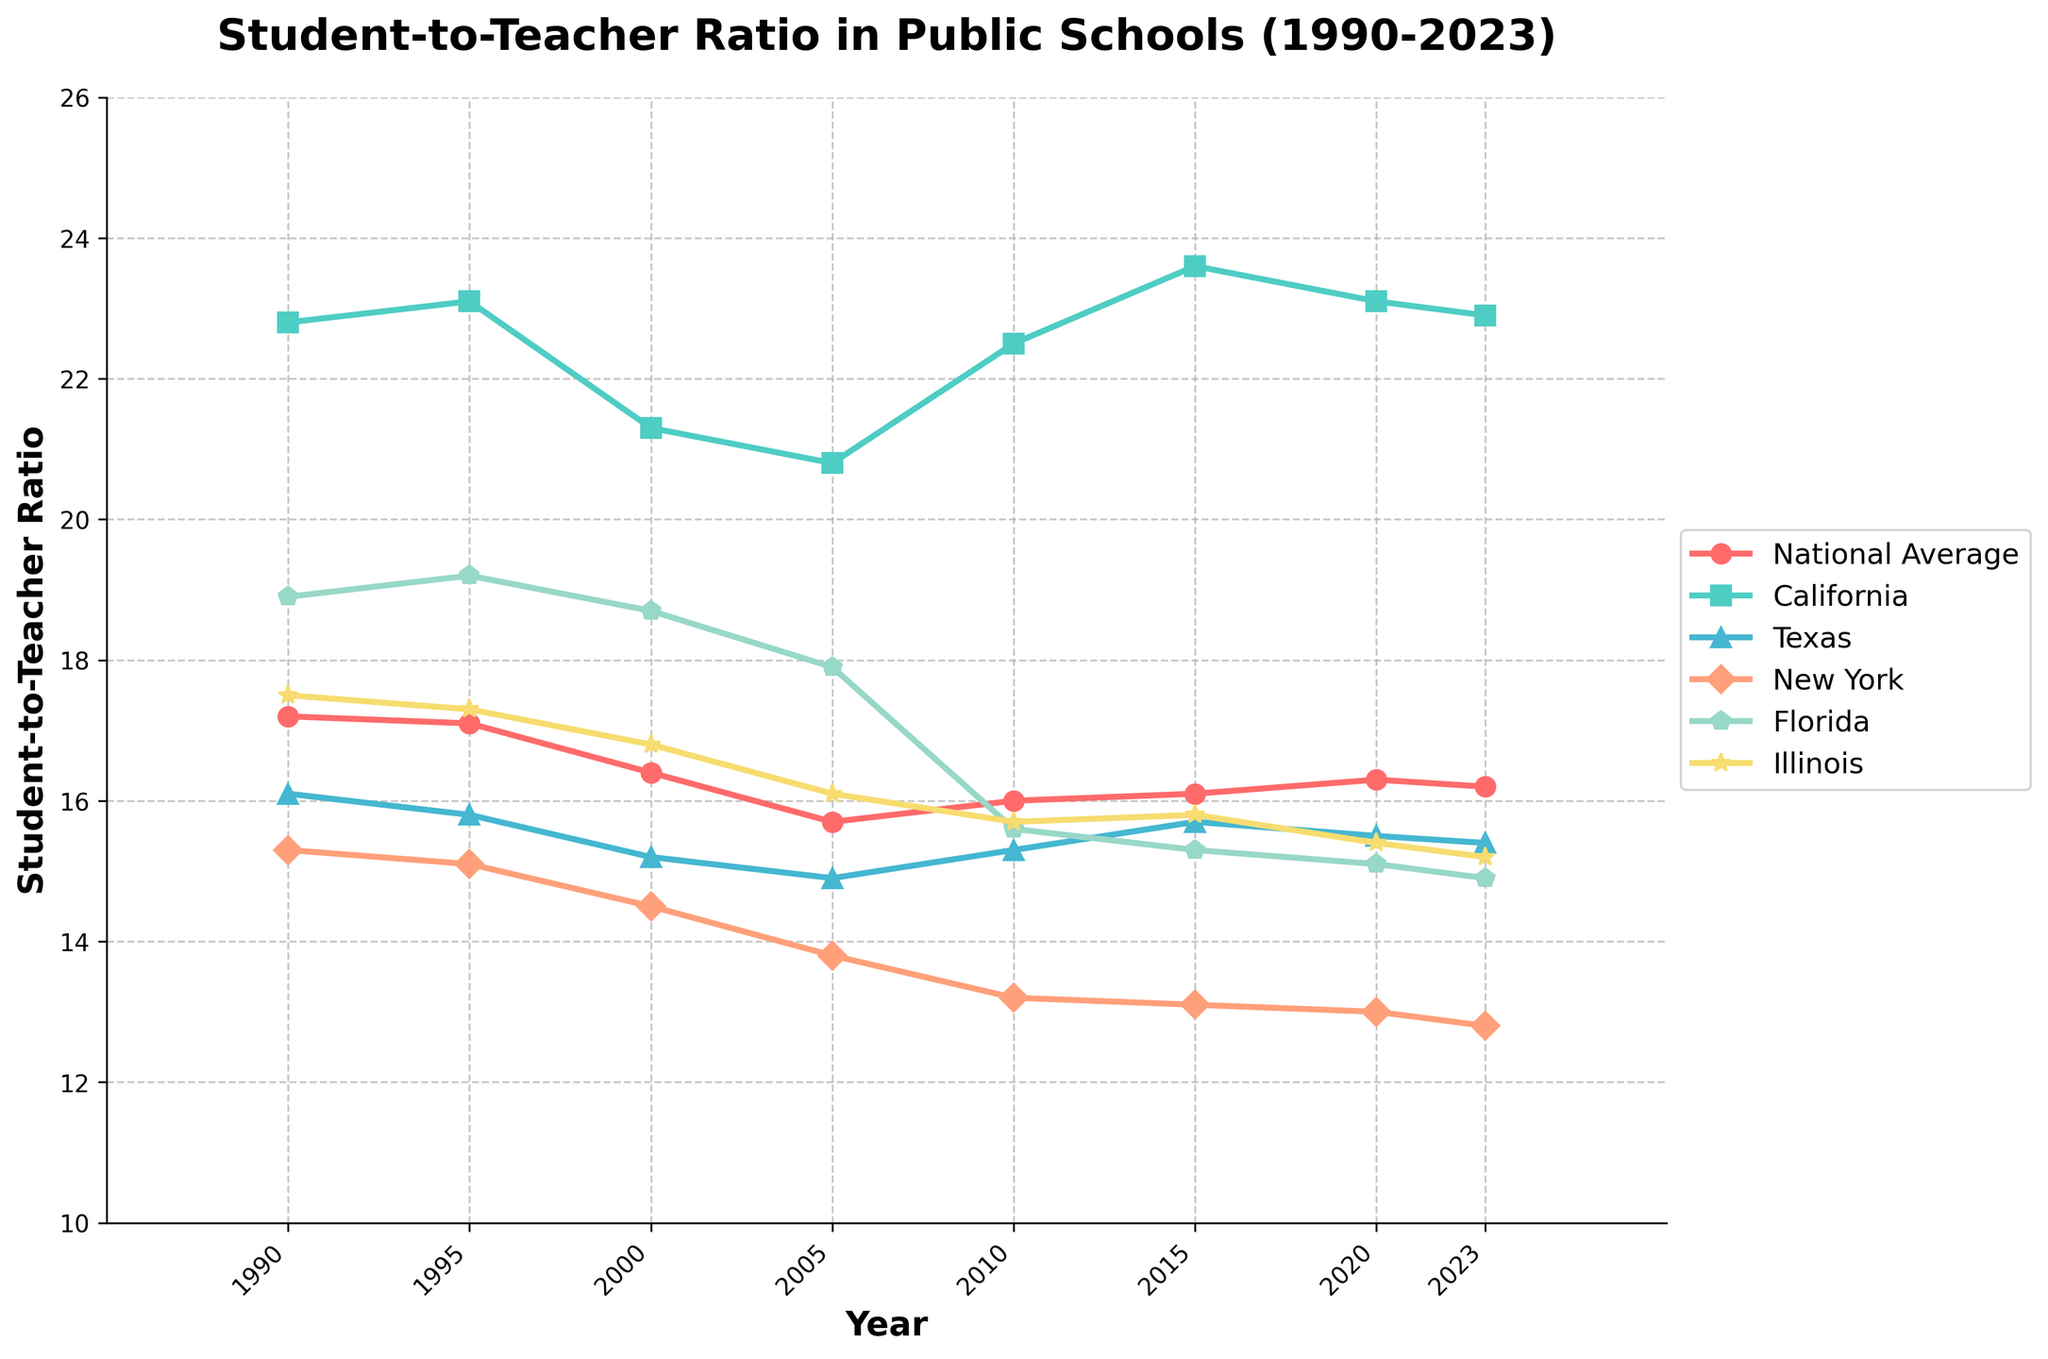What trend does the student-to-teacher ratio in New York show from 1990 to 2023? From the graph, we can observe that the student-to-teacher ratio in New York shows a consistent downward trend from 1990 to 2023. Starting at 15.3 in 1990 and ending at 12.8 in 2023, it generally decreases over the years.
Answer: Downward trend How does the student-to-teacher ratio in Florida in 2023 compare to the year 2000? Looking at the values in the plot for Florida, the student-to-teacher ratio was 18.7 in 2000 and decreased to 14.9 in 2023. This shows a decrease in the student-to-teacher ratio over this period.
Answer: Decreased Which state had the highest student-to-teacher ratio in both 1990 and 2023? The highest student-to-teacher ratio in 1990 was in California at 22.8. In 2023, California still had the highest ratio at 22.9 compared to other states.
Answer: California What is the average student-to-teacher ratio for Texas from 1990 to 2023? To find the average, sum the student-to-teacher ratios for Texas across the years 1990 (16.1), 1995 (15.8), 2000 (15.2), 2005 (14.9), 2010 (15.3), 2015 (15.7), 2020 (15.5), 2023 (15.4). This gives a sum of 124.9. Dividing by 8 (number of years) gives an average of 15.6.
Answer: 15.6 In which year did the national average student-to-teacher ratio hit its lowest point, and what was the value? Observing the graph, the national average student-to-teacher ratio hit its lowest point in 2005 at 15.7.
Answer: 2005, 15.7 Compare the student-to-teacher ratio trends between Illinois and Florida from 1990 to 2023. From the graph, Illinois's student-to-teacher ratio starts at 17.5 in 1990 and decreases to 15.2 in 2023, showing a steady decline overall. Florida starts at 18.9 in 1990 and decreases more sharply to 14.9 in 2023. Both states show a declining trend, but Florida's decline is steeper.
Answer: Both decline, Florida's decline is steeper What visual cue indicates the student-to-teacher ratio trend for the National Average? The National Average student-to-teacher ratio is represented by a red line with circles. Over the years from 1990 to 2023, this line moves mostly downward with minor fluctuations, indicating an overall decline in ratio.
Answer: Red line with circles, mostly downward What was the difference in student-to-teacher ratios between the highest and lowest states in 2010? In 2010, the highest student-to-teacher ratio was in California (22.5), and the lowest was in New York (13.2). The difference is 22.5 - 13.2 = 9.3.
Answer: 9.3 